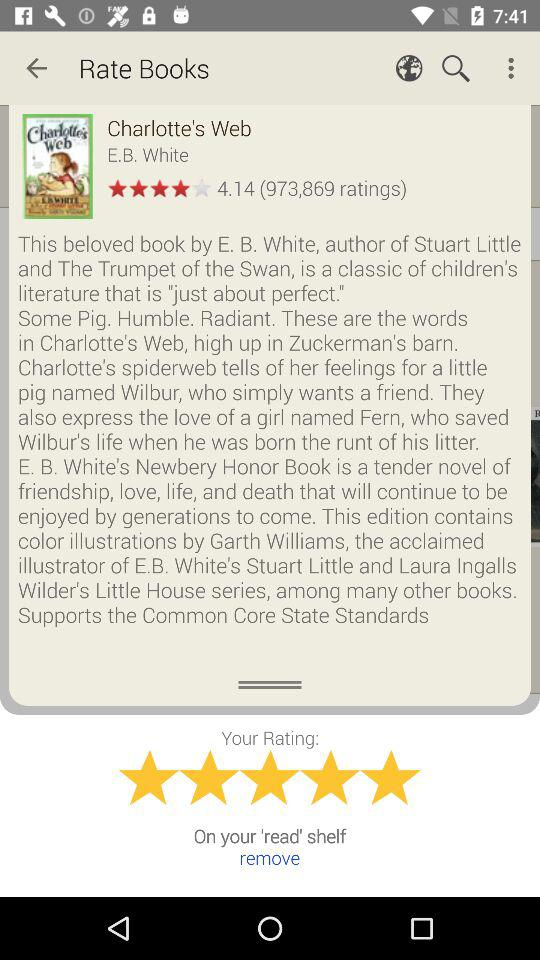What is the name of the pig? The name of the pig is Wilbur. 